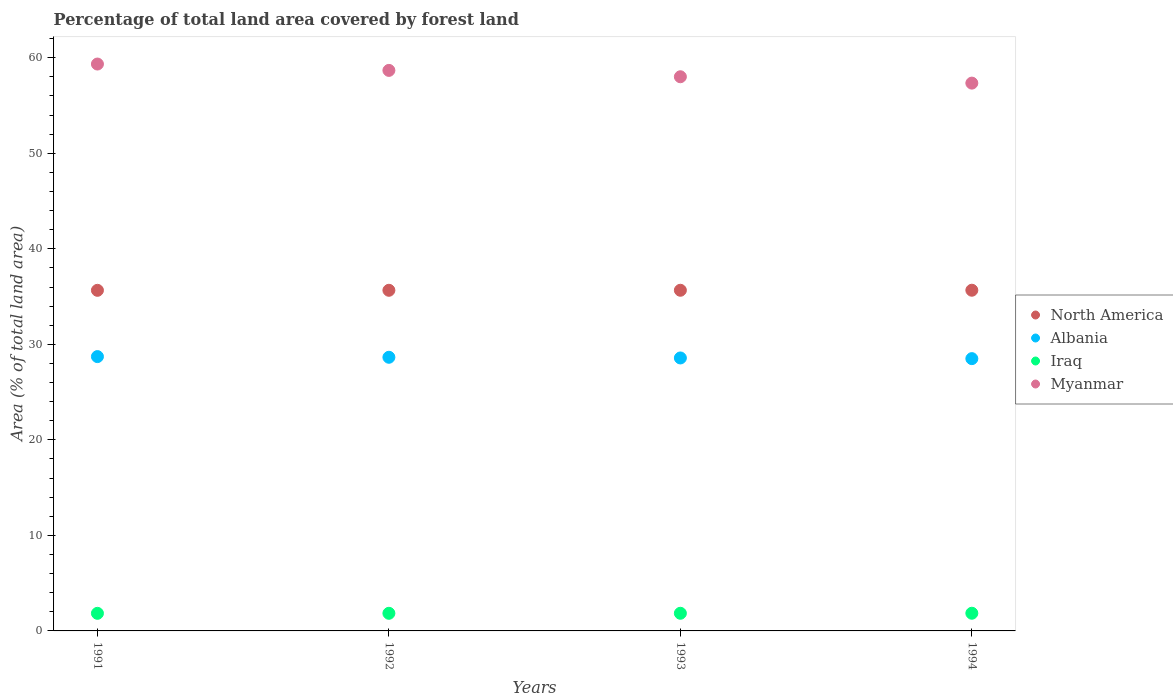How many different coloured dotlines are there?
Provide a succinct answer. 4. Is the number of dotlines equal to the number of legend labels?
Your answer should be very brief. Yes. What is the percentage of forest land in Iraq in 1994?
Ensure brevity in your answer.  1.85. Across all years, what is the maximum percentage of forest land in Myanmar?
Your response must be concise. 59.34. Across all years, what is the minimum percentage of forest land in Albania?
Provide a short and direct response. 28.5. In which year was the percentage of forest land in Iraq maximum?
Make the answer very short. 1994. What is the total percentage of forest land in Myanmar in the graph?
Provide a succinct answer. 233.38. What is the difference between the percentage of forest land in Albania in 1992 and that in 1994?
Offer a very short reply. 0.14. What is the difference between the percentage of forest land in Myanmar in 1991 and the percentage of forest land in Iraq in 1992?
Provide a succinct answer. 57.5. What is the average percentage of forest land in Iraq per year?
Keep it short and to the point. 1.85. In the year 1992, what is the difference between the percentage of forest land in Myanmar and percentage of forest land in North America?
Provide a short and direct response. 23.02. In how many years, is the percentage of forest land in Iraq greater than 10 %?
Your answer should be very brief. 0. What is the ratio of the percentage of forest land in North America in 1993 to that in 1994?
Provide a short and direct response. 1. Is the difference between the percentage of forest land in Myanmar in 1992 and 1993 greater than the difference between the percentage of forest land in North America in 1992 and 1993?
Give a very brief answer. Yes. What is the difference between the highest and the second highest percentage of forest land in North America?
Make the answer very short. 0. What is the difference between the highest and the lowest percentage of forest land in Iraq?
Your answer should be compact. 0.01. Is it the case that in every year, the sum of the percentage of forest land in Iraq and percentage of forest land in Myanmar  is greater than the percentage of forest land in Albania?
Provide a short and direct response. Yes. How many years are there in the graph?
Give a very brief answer. 4. Does the graph contain any zero values?
Provide a short and direct response. No. Does the graph contain grids?
Give a very brief answer. No. How many legend labels are there?
Make the answer very short. 4. How are the legend labels stacked?
Provide a short and direct response. Vertical. What is the title of the graph?
Ensure brevity in your answer.  Percentage of total land area covered by forest land. What is the label or title of the Y-axis?
Give a very brief answer. Area (% of total land area). What is the Area (% of total land area) of North America in 1991?
Your response must be concise. 35.65. What is the Area (% of total land area) of Albania in 1991?
Provide a succinct answer. 28.72. What is the Area (% of total land area) in Iraq in 1991?
Your answer should be very brief. 1.84. What is the Area (% of total land area) of Myanmar in 1991?
Provide a short and direct response. 59.34. What is the Area (% of total land area) in North America in 1992?
Your answer should be compact. 35.66. What is the Area (% of total land area) of Albania in 1992?
Your answer should be compact. 28.65. What is the Area (% of total land area) of Iraq in 1992?
Your answer should be very brief. 1.84. What is the Area (% of total land area) in Myanmar in 1992?
Your answer should be compact. 58.68. What is the Area (% of total land area) of North America in 1993?
Offer a very short reply. 35.66. What is the Area (% of total land area) in Albania in 1993?
Give a very brief answer. 28.57. What is the Area (% of total land area) of Iraq in 1993?
Offer a terse response. 1.85. What is the Area (% of total land area) in Myanmar in 1993?
Your response must be concise. 58.01. What is the Area (% of total land area) of North America in 1994?
Offer a very short reply. 35.66. What is the Area (% of total land area) in Albania in 1994?
Make the answer very short. 28.5. What is the Area (% of total land area) in Iraq in 1994?
Keep it short and to the point. 1.85. What is the Area (% of total land area) of Myanmar in 1994?
Your answer should be very brief. 57.35. Across all years, what is the maximum Area (% of total land area) in North America?
Offer a terse response. 35.66. Across all years, what is the maximum Area (% of total land area) of Albania?
Provide a succinct answer. 28.72. Across all years, what is the maximum Area (% of total land area) in Iraq?
Your response must be concise. 1.85. Across all years, what is the maximum Area (% of total land area) in Myanmar?
Ensure brevity in your answer.  59.34. Across all years, what is the minimum Area (% of total land area) of North America?
Keep it short and to the point. 35.65. Across all years, what is the minimum Area (% of total land area) in Albania?
Keep it short and to the point. 28.5. Across all years, what is the minimum Area (% of total land area) in Iraq?
Offer a very short reply. 1.84. Across all years, what is the minimum Area (% of total land area) of Myanmar?
Your answer should be compact. 57.35. What is the total Area (% of total land area) of North America in the graph?
Offer a terse response. 142.64. What is the total Area (% of total land area) of Albania in the graph?
Provide a short and direct response. 114.44. What is the total Area (% of total land area) in Iraq in the graph?
Ensure brevity in your answer.  7.39. What is the total Area (% of total land area) in Myanmar in the graph?
Offer a very short reply. 233.38. What is the difference between the Area (% of total land area) of North America in 1991 and that in 1992?
Make the answer very short. -0. What is the difference between the Area (% of total land area) of Albania in 1991 and that in 1992?
Provide a succinct answer. 0.07. What is the difference between the Area (% of total land area) in Iraq in 1991 and that in 1992?
Keep it short and to the point. -0. What is the difference between the Area (% of total land area) of Myanmar in 1991 and that in 1992?
Give a very brief answer. 0.67. What is the difference between the Area (% of total land area) in North America in 1991 and that in 1993?
Your response must be concise. -0.01. What is the difference between the Area (% of total land area) in Albania in 1991 and that in 1993?
Give a very brief answer. 0.14. What is the difference between the Area (% of total land area) of Iraq in 1991 and that in 1993?
Give a very brief answer. -0.01. What is the difference between the Area (% of total land area) of Myanmar in 1991 and that in 1993?
Your response must be concise. 1.33. What is the difference between the Area (% of total land area) of North America in 1991 and that in 1994?
Your answer should be compact. -0.01. What is the difference between the Area (% of total land area) of Albania in 1991 and that in 1994?
Keep it short and to the point. 0.21. What is the difference between the Area (% of total land area) in Iraq in 1991 and that in 1994?
Your answer should be compact. -0.01. What is the difference between the Area (% of total land area) in Myanmar in 1991 and that in 1994?
Your answer should be very brief. 2. What is the difference between the Area (% of total land area) in North America in 1992 and that in 1993?
Offer a very short reply. -0. What is the difference between the Area (% of total land area) of Albania in 1992 and that in 1993?
Offer a terse response. 0.07. What is the difference between the Area (% of total land area) of Iraq in 1992 and that in 1993?
Provide a short and direct response. -0. What is the difference between the Area (% of total land area) of Myanmar in 1992 and that in 1993?
Give a very brief answer. 0.67. What is the difference between the Area (% of total land area) of North America in 1992 and that in 1994?
Provide a succinct answer. -0.01. What is the difference between the Area (% of total land area) in Albania in 1992 and that in 1994?
Offer a terse response. 0.14. What is the difference between the Area (% of total land area) of Iraq in 1992 and that in 1994?
Provide a succinct answer. -0.01. What is the difference between the Area (% of total land area) of Myanmar in 1992 and that in 1994?
Offer a very short reply. 1.33. What is the difference between the Area (% of total land area) in North America in 1993 and that in 1994?
Your response must be concise. -0. What is the difference between the Area (% of total land area) in Albania in 1993 and that in 1994?
Make the answer very short. 0.07. What is the difference between the Area (% of total land area) in Iraq in 1993 and that in 1994?
Your answer should be compact. -0. What is the difference between the Area (% of total land area) in Myanmar in 1993 and that in 1994?
Make the answer very short. 0.67. What is the difference between the Area (% of total land area) in North America in 1991 and the Area (% of total land area) in Albania in 1992?
Give a very brief answer. 7.01. What is the difference between the Area (% of total land area) of North America in 1991 and the Area (% of total land area) of Iraq in 1992?
Provide a short and direct response. 33.81. What is the difference between the Area (% of total land area) of North America in 1991 and the Area (% of total land area) of Myanmar in 1992?
Your answer should be compact. -23.02. What is the difference between the Area (% of total land area) of Albania in 1991 and the Area (% of total land area) of Iraq in 1992?
Offer a terse response. 26.87. What is the difference between the Area (% of total land area) in Albania in 1991 and the Area (% of total land area) in Myanmar in 1992?
Make the answer very short. -29.96. What is the difference between the Area (% of total land area) of Iraq in 1991 and the Area (% of total land area) of Myanmar in 1992?
Offer a very short reply. -56.84. What is the difference between the Area (% of total land area) in North America in 1991 and the Area (% of total land area) in Albania in 1993?
Provide a succinct answer. 7.08. What is the difference between the Area (% of total land area) of North America in 1991 and the Area (% of total land area) of Iraq in 1993?
Offer a terse response. 33.81. What is the difference between the Area (% of total land area) of North America in 1991 and the Area (% of total land area) of Myanmar in 1993?
Ensure brevity in your answer.  -22.36. What is the difference between the Area (% of total land area) of Albania in 1991 and the Area (% of total land area) of Iraq in 1993?
Offer a very short reply. 26.87. What is the difference between the Area (% of total land area) of Albania in 1991 and the Area (% of total land area) of Myanmar in 1993?
Your answer should be very brief. -29.29. What is the difference between the Area (% of total land area) of Iraq in 1991 and the Area (% of total land area) of Myanmar in 1993?
Provide a succinct answer. -56.17. What is the difference between the Area (% of total land area) of North America in 1991 and the Area (% of total land area) of Albania in 1994?
Make the answer very short. 7.15. What is the difference between the Area (% of total land area) of North America in 1991 and the Area (% of total land area) of Iraq in 1994?
Provide a succinct answer. 33.8. What is the difference between the Area (% of total land area) in North America in 1991 and the Area (% of total land area) in Myanmar in 1994?
Make the answer very short. -21.69. What is the difference between the Area (% of total land area) in Albania in 1991 and the Area (% of total land area) in Iraq in 1994?
Your answer should be very brief. 26.87. What is the difference between the Area (% of total land area) in Albania in 1991 and the Area (% of total land area) in Myanmar in 1994?
Ensure brevity in your answer.  -28.63. What is the difference between the Area (% of total land area) in Iraq in 1991 and the Area (% of total land area) in Myanmar in 1994?
Your answer should be compact. -55.5. What is the difference between the Area (% of total land area) of North America in 1992 and the Area (% of total land area) of Albania in 1993?
Offer a very short reply. 7.08. What is the difference between the Area (% of total land area) of North America in 1992 and the Area (% of total land area) of Iraq in 1993?
Your response must be concise. 33.81. What is the difference between the Area (% of total land area) in North America in 1992 and the Area (% of total land area) in Myanmar in 1993?
Offer a very short reply. -22.35. What is the difference between the Area (% of total land area) in Albania in 1992 and the Area (% of total land area) in Iraq in 1993?
Your answer should be compact. 26.8. What is the difference between the Area (% of total land area) in Albania in 1992 and the Area (% of total land area) in Myanmar in 1993?
Provide a short and direct response. -29.37. What is the difference between the Area (% of total land area) in Iraq in 1992 and the Area (% of total land area) in Myanmar in 1993?
Ensure brevity in your answer.  -56.17. What is the difference between the Area (% of total land area) of North America in 1992 and the Area (% of total land area) of Albania in 1994?
Offer a terse response. 7.15. What is the difference between the Area (% of total land area) in North America in 1992 and the Area (% of total land area) in Iraq in 1994?
Give a very brief answer. 33.81. What is the difference between the Area (% of total land area) in North America in 1992 and the Area (% of total land area) in Myanmar in 1994?
Offer a terse response. -21.69. What is the difference between the Area (% of total land area) of Albania in 1992 and the Area (% of total land area) of Iraq in 1994?
Make the answer very short. 26.79. What is the difference between the Area (% of total land area) of Albania in 1992 and the Area (% of total land area) of Myanmar in 1994?
Your answer should be compact. -28.7. What is the difference between the Area (% of total land area) of Iraq in 1992 and the Area (% of total land area) of Myanmar in 1994?
Provide a short and direct response. -55.5. What is the difference between the Area (% of total land area) in North America in 1993 and the Area (% of total land area) in Albania in 1994?
Provide a short and direct response. 7.16. What is the difference between the Area (% of total land area) in North America in 1993 and the Area (% of total land area) in Iraq in 1994?
Provide a short and direct response. 33.81. What is the difference between the Area (% of total land area) of North America in 1993 and the Area (% of total land area) of Myanmar in 1994?
Keep it short and to the point. -21.68. What is the difference between the Area (% of total land area) in Albania in 1993 and the Area (% of total land area) in Iraq in 1994?
Your answer should be compact. 26.72. What is the difference between the Area (% of total land area) of Albania in 1993 and the Area (% of total land area) of Myanmar in 1994?
Make the answer very short. -28.77. What is the difference between the Area (% of total land area) in Iraq in 1993 and the Area (% of total land area) in Myanmar in 1994?
Provide a succinct answer. -55.5. What is the average Area (% of total land area) of North America per year?
Offer a very short reply. 35.66. What is the average Area (% of total land area) in Albania per year?
Offer a terse response. 28.61. What is the average Area (% of total land area) of Iraq per year?
Ensure brevity in your answer.  1.85. What is the average Area (% of total land area) of Myanmar per year?
Your response must be concise. 58.34. In the year 1991, what is the difference between the Area (% of total land area) in North America and Area (% of total land area) in Albania?
Ensure brevity in your answer.  6.94. In the year 1991, what is the difference between the Area (% of total land area) in North America and Area (% of total land area) in Iraq?
Your answer should be very brief. 33.81. In the year 1991, what is the difference between the Area (% of total land area) of North America and Area (% of total land area) of Myanmar?
Offer a terse response. -23.69. In the year 1991, what is the difference between the Area (% of total land area) of Albania and Area (% of total land area) of Iraq?
Your answer should be compact. 26.88. In the year 1991, what is the difference between the Area (% of total land area) in Albania and Area (% of total land area) in Myanmar?
Provide a short and direct response. -30.63. In the year 1991, what is the difference between the Area (% of total land area) in Iraq and Area (% of total land area) in Myanmar?
Make the answer very short. -57.5. In the year 1992, what is the difference between the Area (% of total land area) of North America and Area (% of total land area) of Albania?
Your response must be concise. 7.01. In the year 1992, what is the difference between the Area (% of total land area) of North America and Area (% of total land area) of Iraq?
Make the answer very short. 33.81. In the year 1992, what is the difference between the Area (% of total land area) in North America and Area (% of total land area) in Myanmar?
Keep it short and to the point. -23.02. In the year 1992, what is the difference between the Area (% of total land area) of Albania and Area (% of total land area) of Iraq?
Provide a succinct answer. 26.8. In the year 1992, what is the difference between the Area (% of total land area) in Albania and Area (% of total land area) in Myanmar?
Provide a succinct answer. -30.03. In the year 1992, what is the difference between the Area (% of total land area) in Iraq and Area (% of total land area) in Myanmar?
Provide a succinct answer. -56.83. In the year 1993, what is the difference between the Area (% of total land area) in North America and Area (% of total land area) in Albania?
Your answer should be very brief. 7.09. In the year 1993, what is the difference between the Area (% of total land area) of North America and Area (% of total land area) of Iraq?
Offer a terse response. 33.81. In the year 1993, what is the difference between the Area (% of total land area) of North America and Area (% of total land area) of Myanmar?
Provide a succinct answer. -22.35. In the year 1993, what is the difference between the Area (% of total land area) of Albania and Area (% of total land area) of Iraq?
Ensure brevity in your answer.  26.73. In the year 1993, what is the difference between the Area (% of total land area) of Albania and Area (% of total land area) of Myanmar?
Your answer should be compact. -29.44. In the year 1993, what is the difference between the Area (% of total land area) in Iraq and Area (% of total land area) in Myanmar?
Give a very brief answer. -56.16. In the year 1994, what is the difference between the Area (% of total land area) of North America and Area (% of total land area) of Albania?
Offer a very short reply. 7.16. In the year 1994, what is the difference between the Area (% of total land area) of North America and Area (% of total land area) of Iraq?
Your answer should be compact. 33.81. In the year 1994, what is the difference between the Area (% of total land area) of North America and Area (% of total land area) of Myanmar?
Your response must be concise. -21.68. In the year 1994, what is the difference between the Area (% of total land area) of Albania and Area (% of total land area) of Iraq?
Ensure brevity in your answer.  26.65. In the year 1994, what is the difference between the Area (% of total land area) of Albania and Area (% of total land area) of Myanmar?
Your answer should be very brief. -28.84. In the year 1994, what is the difference between the Area (% of total land area) of Iraq and Area (% of total land area) of Myanmar?
Provide a succinct answer. -55.5. What is the ratio of the Area (% of total land area) of North America in 1991 to that in 1992?
Your answer should be very brief. 1. What is the ratio of the Area (% of total land area) of Albania in 1991 to that in 1992?
Provide a succinct answer. 1. What is the ratio of the Area (% of total land area) in Iraq in 1991 to that in 1992?
Provide a short and direct response. 1. What is the ratio of the Area (% of total land area) of Myanmar in 1991 to that in 1992?
Give a very brief answer. 1.01. What is the ratio of the Area (% of total land area) in North America in 1991 to that in 1993?
Ensure brevity in your answer.  1. What is the ratio of the Area (% of total land area) in Myanmar in 1991 to that in 1993?
Offer a very short reply. 1.02. What is the ratio of the Area (% of total land area) of North America in 1991 to that in 1994?
Offer a terse response. 1. What is the ratio of the Area (% of total land area) of Albania in 1991 to that in 1994?
Your answer should be compact. 1.01. What is the ratio of the Area (% of total land area) of Iraq in 1991 to that in 1994?
Your response must be concise. 0.99. What is the ratio of the Area (% of total land area) in Myanmar in 1991 to that in 1994?
Your response must be concise. 1.03. What is the ratio of the Area (% of total land area) in North America in 1992 to that in 1993?
Your response must be concise. 1. What is the ratio of the Area (% of total land area) of Albania in 1992 to that in 1993?
Offer a terse response. 1. What is the ratio of the Area (% of total land area) in Iraq in 1992 to that in 1993?
Give a very brief answer. 1. What is the ratio of the Area (% of total land area) of Myanmar in 1992 to that in 1993?
Make the answer very short. 1.01. What is the ratio of the Area (% of total land area) in North America in 1992 to that in 1994?
Ensure brevity in your answer.  1. What is the ratio of the Area (% of total land area) in Albania in 1992 to that in 1994?
Give a very brief answer. 1. What is the ratio of the Area (% of total land area) in Iraq in 1992 to that in 1994?
Make the answer very short. 1. What is the ratio of the Area (% of total land area) in Myanmar in 1992 to that in 1994?
Ensure brevity in your answer.  1.02. What is the ratio of the Area (% of total land area) in North America in 1993 to that in 1994?
Offer a very short reply. 1. What is the ratio of the Area (% of total land area) in Albania in 1993 to that in 1994?
Offer a very short reply. 1. What is the ratio of the Area (% of total land area) in Iraq in 1993 to that in 1994?
Make the answer very short. 1. What is the ratio of the Area (% of total land area) of Myanmar in 1993 to that in 1994?
Give a very brief answer. 1.01. What is the difference between the highest and the second highest Area (% of total land area) in North America?
Make the answer very short. 0. What is the difference between the highest and the second highest Area (% of total land area) of Albania?
Provide a succinct answer. 0.07. What is the difference between the highest and the second highest Area (% of total land area) in Iraq?
Offer a very short reply. 0. What is the difference between the highest and the second highest Area (% of total land area) of Myanmar?
Provide a succinct answer. 0.67. What is the difference between the highest and the lowest Area (% of total land area) in North America?
Offer a very short reply. 0.01. What is the difference between the highest and the lowest Area (% of total land area) in Albania?
Your answer should be compact. 0.21. What is the difference between the highest and the lowest Area (% of total land area) of Iraq?
Your response must be concise. 0.01. What is the difference between the highest and the lowest Area (% of total land area) in Myanmar?
Ensure brevity in your answer.  2. 